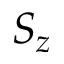Convert formula to latex. <formula><loc_0><loc_0><loc_500><loc_500>S _ { z }</formula> 